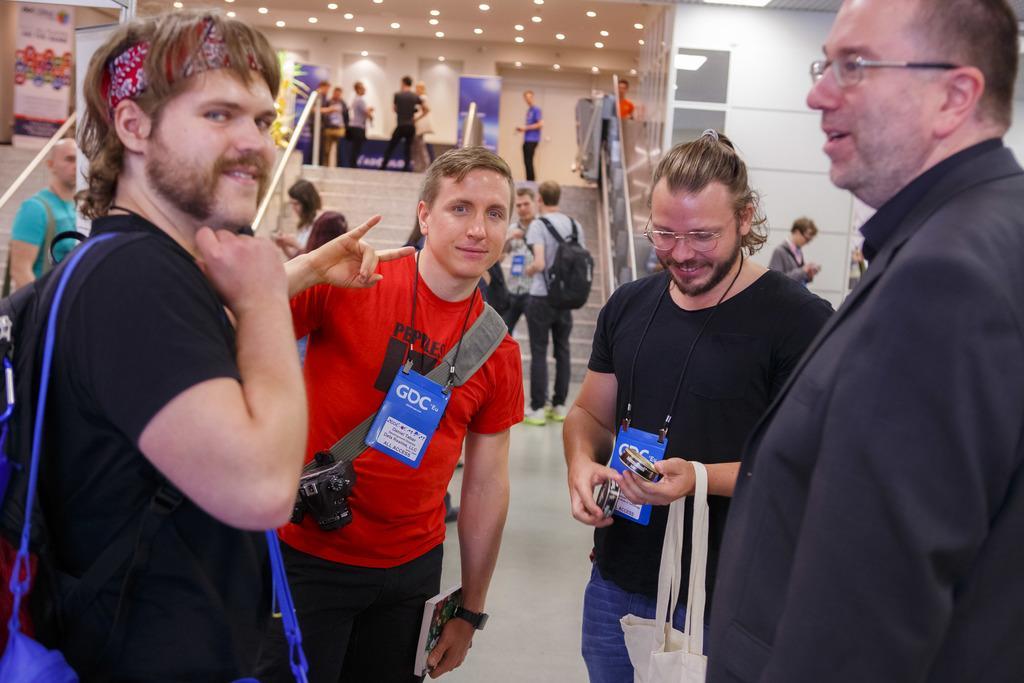In one or two sentences, can you explain what this image depicts? In this image I can see number of people are standing and I can see most of them are carrying bags. In the front I can see two of them are wearing ID cards and I can also see a black colour camera in the front. In the background I can see stairs, railings, number of boards, number of lights, a plant and on these boards I can see something is written. 